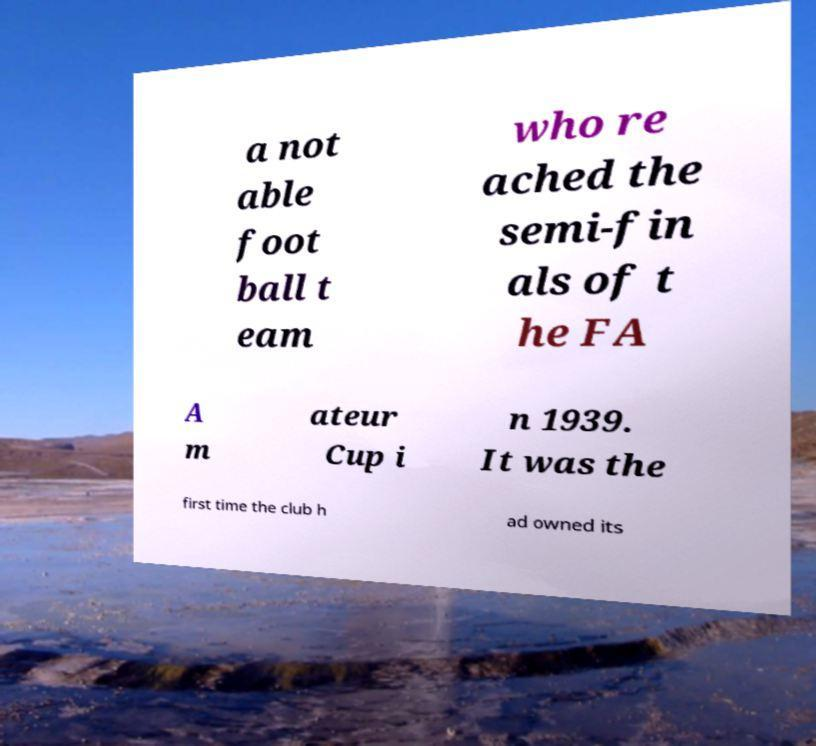What messages or text are displayed in this image? I need them in a readable, typed format. a not able foot ball t eam who re ached the semi-fin als of t he FA A m ateur Cup i n 1939. It was the first time the club h ad owned its 